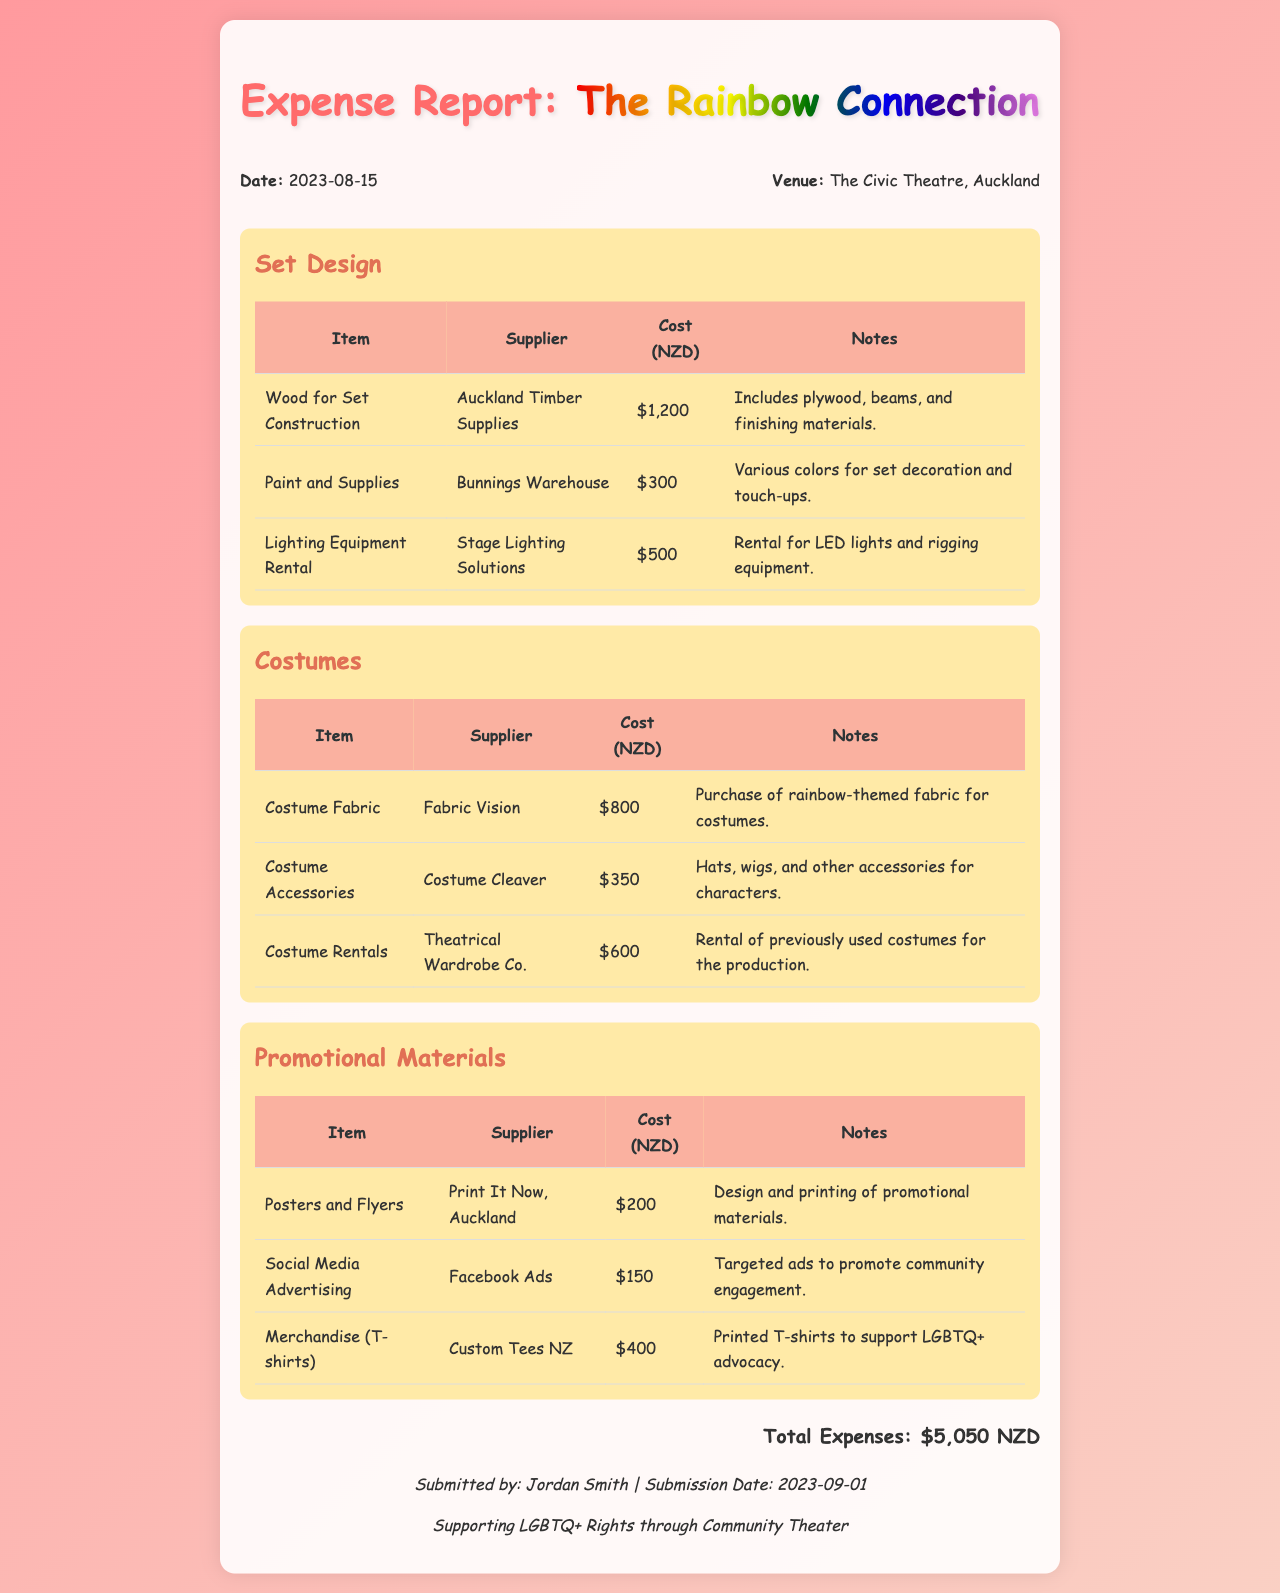what is the total expense amount? The total expenses are summed up from all categories in the document, equaling $1,200 + $300 + $500 + $800 + $350 + $600 + $200 + $150 + $400 = $5,050.
Answer: $5,050 who submitted the expense report? The report was submitted by Jordan Smith, as indicated in the footer of the document.
Answer: Jordan Smith what is the date of the report submission? The submission date is specifically mentioned in the footer of the document, which is 2023-09-01.
Answer: 2023-09-01 which venue hosted the production? The venue is specifically named in the header information as The Civic Theatre, Auckland.
Answer: The Civic Theatre, Auckland how much was spent on social media advertising? The cost for social media advertising can be found in the promotional materials section, which states $150.
Answer: $150 what type of fabric was used for the costumes? The document mentions rainbow-themed fabric for costumes found in the costumes section, specifically under Costume Fabric.
Answer: rainbow-themed fabric how many items are listed under Set Design? The Set Design section lists three items: Wood for Set Construction, Paint and Supplies, and Lighting Equipment Rental.
Answer: 3 what supplier provided the costume accessories? The supplier for costume accessories is mentioned in the costumes section as Costume Cleaver.
Answer: Costume Cleaver what is the cost for printed T-shirts? The cost for Merchandise (T-shirts) is detailed under promotional materials as $400.
Answer: $400 